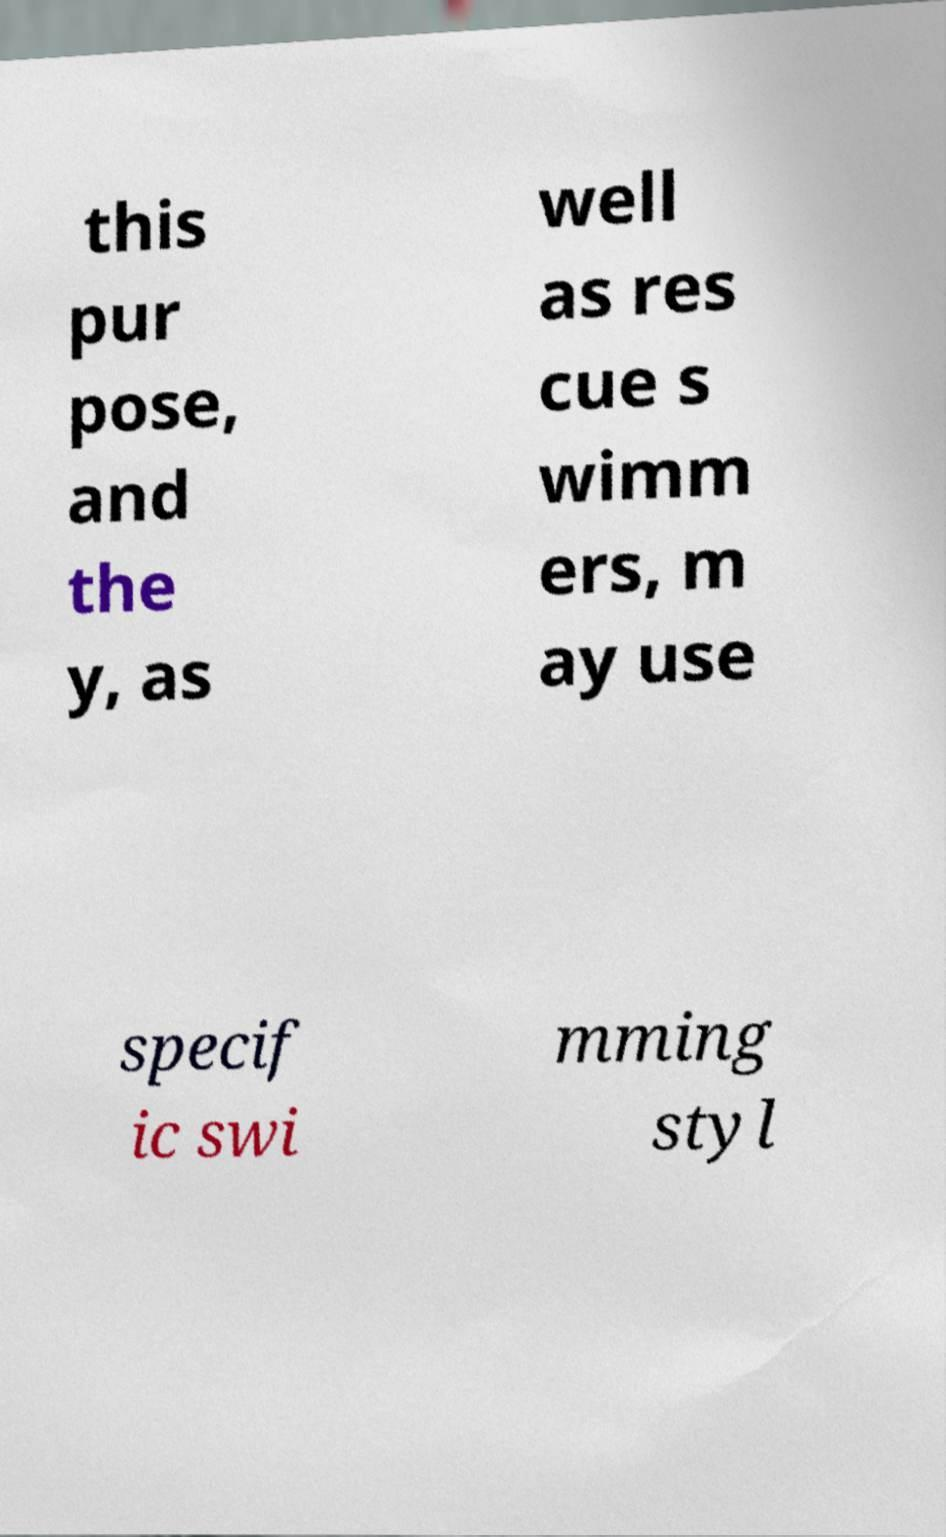Can you read and provide the text displayed in the image?This photo seems to have some interesting text. Can you extract and type it out for me? this pur pose, and the y, as well as res cue s wimm ers, m ay use specif ic swi mming styl 